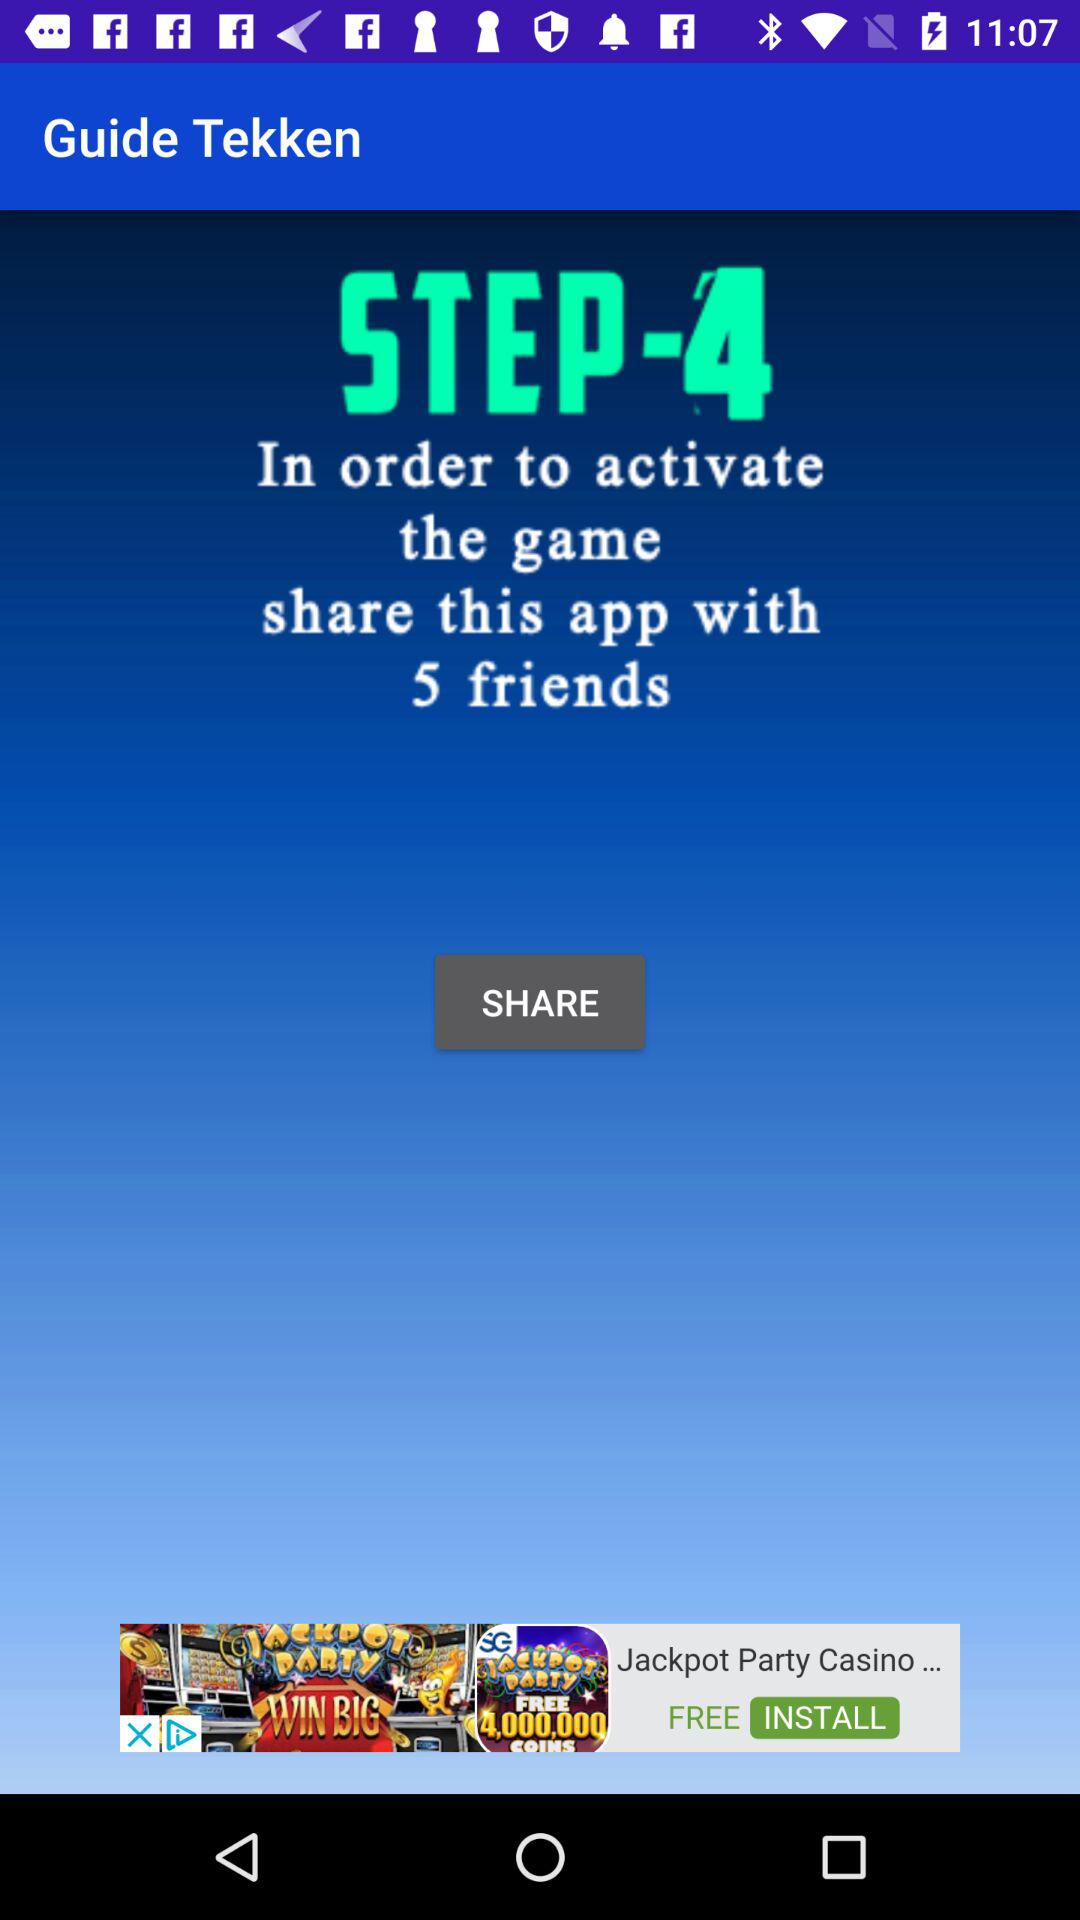Who is this application powered by?
When the provided information is insufficient, respond with <no answer>. <no answer> 